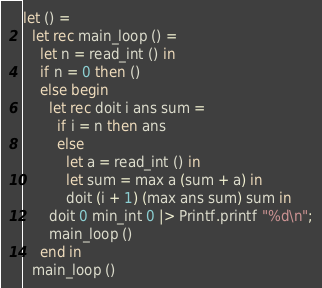<code> <loc_0><loc_0><loc_500><loc_500><_OCaml_>let () =
  let rec main_loop () =
    let n = read_int () in
    if n = 0 then ()
    else begin
      let rec doit i ans sum =
        if i = n then ans
        else
          let a = read_int () in
          let sum = max a (sum + a) in
          doit (i + 1) (max ans sum) sum in
      doit 0 min_int 0 |> Printf.printf "%d\n";
      main_loop ()
    end in
  main_loop ()</code> 